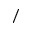<formula> <loc_0><loc_0><loc_500><loc_500>/</formula> 